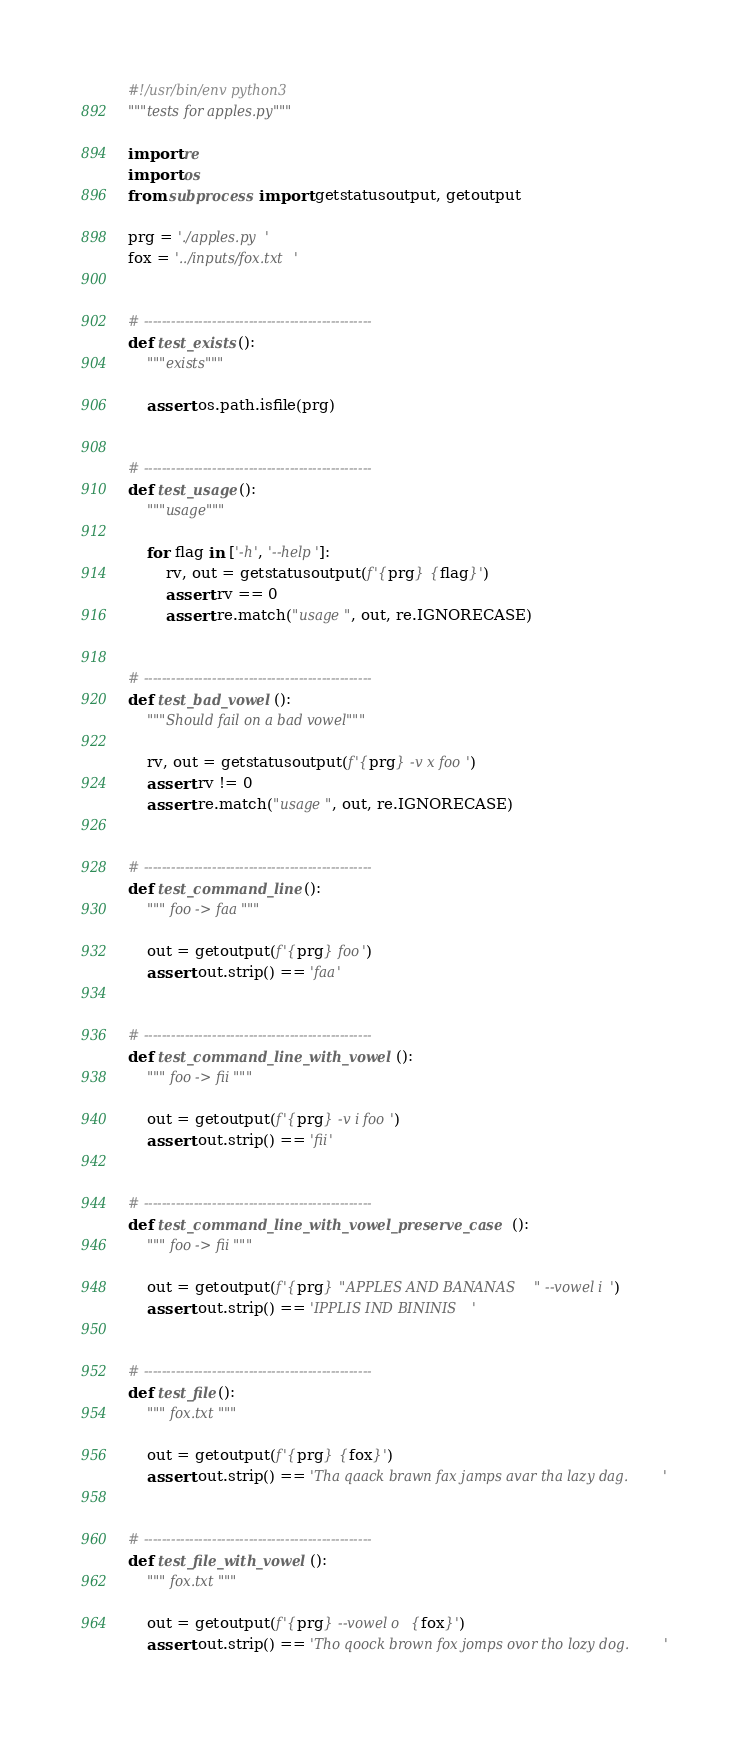Convert code to text. <code><loc_0><loc_0><loc_500><loc_500><_Python_>#!/usr/bin/env python3
"""tests for apples.py"""

import re
import os
from subprocess import getstatusoutput, getoutput

prg = './apples.py'
fox = '../inputs/fox.txt'


# --------------------------------------------------
def test_exists():
    """exists"""

    assert os.path.isfile(prg)


# --------------------------------------------------
def test_usage():
    """usage"""

    for flag in ['-h', '--help']:
        rv, out = getstatusoutput(f'{prg} {flag}')
        assert rv == 0
        assert re.match("usage", out, re.IGNORECASE)


# --------------------------------------------------
def test_bad_vowel():
    """Should fail on a bad vowel"""

    rv, out = getstatusoutput(f'{prg} -v x foo')
    assert rv != 0
    assert re.match("usage", out, re.IGNORECASE)


# --------------------------------------------------
def test_command_line():
    """ foo -> faa """

    out = getoutput(f'{prg} foo')
    assert out.strip() == 'faa'


# --------------------------------------------------
def test_command_line_with_vowel():
    """ foo -> fii """

    out = getoutput(f'{prg} -v i foo')
    assert out.strip() == 'fii'


# --------------------------------------------------
def test_command_line_with_vowel_preserve_case():
    """ foo -> fii """

    out = getoutput(f'{prg} "APPLES AND BANANAS" --vowel i')
    assert out.strip() == 'IPPLIS IND BININIS'


# --------------------------------------------------
def test_file():
    """ fox.txt """

    out = getoutput(f'{prg} {fox}')
    assert out.strip() == 'Tha qaack brawn fax jamps avar tha lazy dag.'


# --------------------------------------------------
def test_file_with_vowel():
    """ fox.txt """

    out = getoutput(f'{prg} --vowel o {fox}')
    assert out.strip() == 'Tho qoock brown fox jomps ovor tho lozy dog.'
</code> 